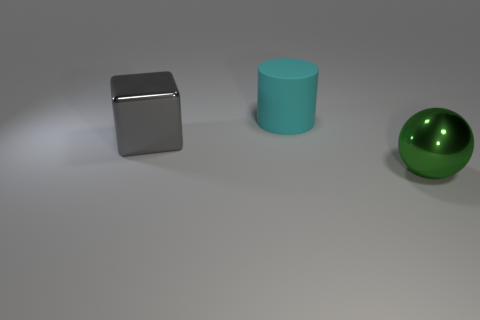Add 1 large rubber cylinders. How many objects exist? 4 Add 3 gray rubber objects. How many gray rubber objects exist? 3 Subtract 0 brown blocks. How many objects are left? 3 Subtract all cylinders. How many objects are left? 2 Subtract all red balls. Subtract all blue cylinders. How many balls are left? 1 Subtract all green objects. Subtract all big green things. How many objects are left? 1 Add 1 metallic objects. How many metallic objects are left? 3 